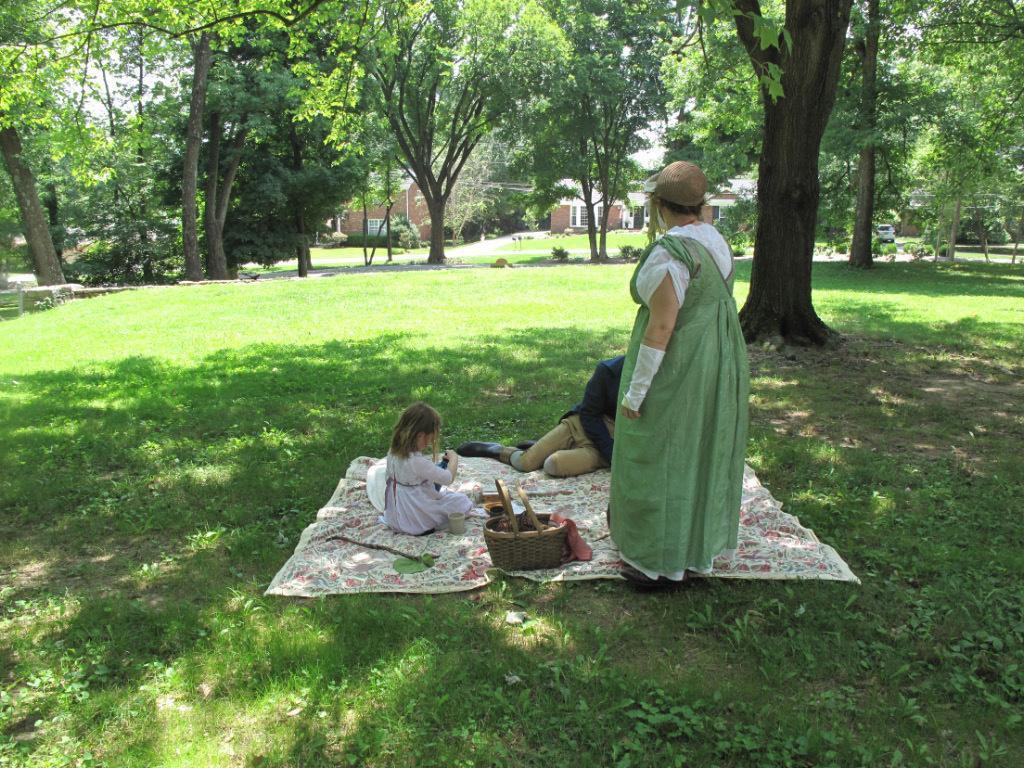Can you describe this image briefly? The picture is taken in a garden. In the center of the picture there are woman, kid and a person sitting on a mat, on the mat there is a basket. In the foreground there are plants, grass and a tree. In the background there are trees, plants and buildings. 